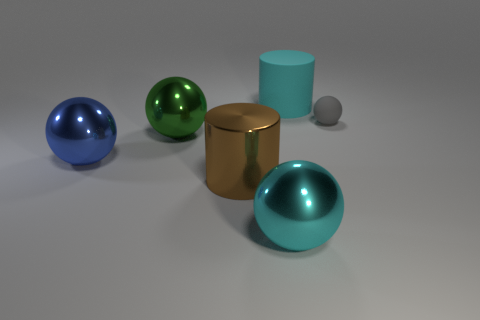Subtract all green balls. How many balls are left? 3 Add 2 blue objects. How many objects exist? 8 Subtract all blue balls. How many balls are left? 3 Subtract all spheres. How many objects are left? 2 Subtract all spheres. Subtract all large cyan matte things. How many objects are left? 1 Add 2 cyan rubber things. How many cyan rubber things are left? 3 Add 6 brown spheres. How many brown spheres exist? 6 Subtract 1 green balls. How many objects are left? 5 Subtract all green cylinders. Subtract all gray cubes. How many cylinders are left? 2 Subtract all cyan spheres. How many brown cylinders are left? 1 